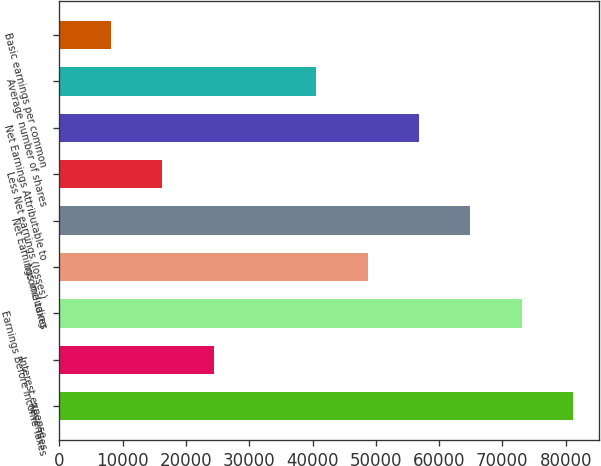Convert chart to OTSL. <chart><loc_0><loc_0><loc_500><loc_500><bar_chart><fcel>Revenues<fcel>Interest expense<fcel>Earnings Before Income Taxes<fcel>Income taxes<fcel>Net Earnings Including<fcel>Less Net earnings (losses)<fcel>Net Earnings Attributable to<fcel>Average number of shares<fcel>Basic earnings per common<nl><fcel>81201<fcel>24362.7<fcel>73081.3<fcel>48722<fcel>64961.5<fcel>16243<fcel>56841.8<fcel>40602.2<fcel>8123.19<nl></chart> 